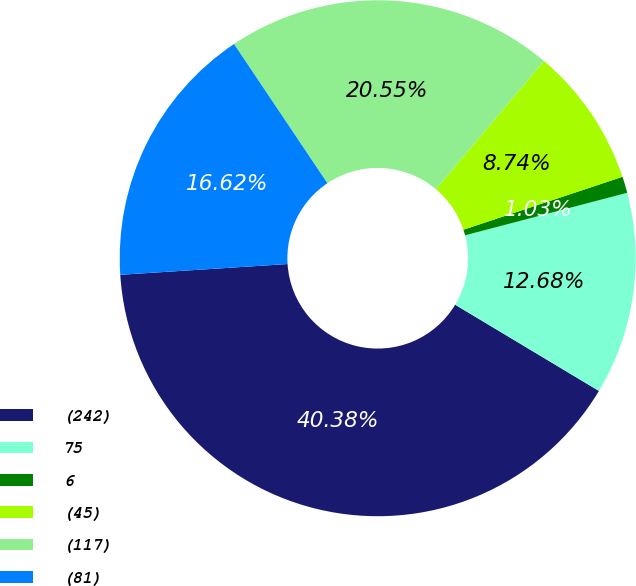Convert chart. <chart><loc_0><loc_0><loc_500><loc_500><pie_chart><fcel>(242)<fcel>75<fcel>6<fcel>(45)<fcel>(117)<fcel>(81)<nl><fcel>40.38%<fcel>12.68%<fcel>1.03%<fcel>8.74%<fcel>20.55%<fcel>16.62%<nl></chart> 